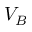<formula> <loc_0><loc_0><loc_500><loc_500>V _ { B }</formula> 